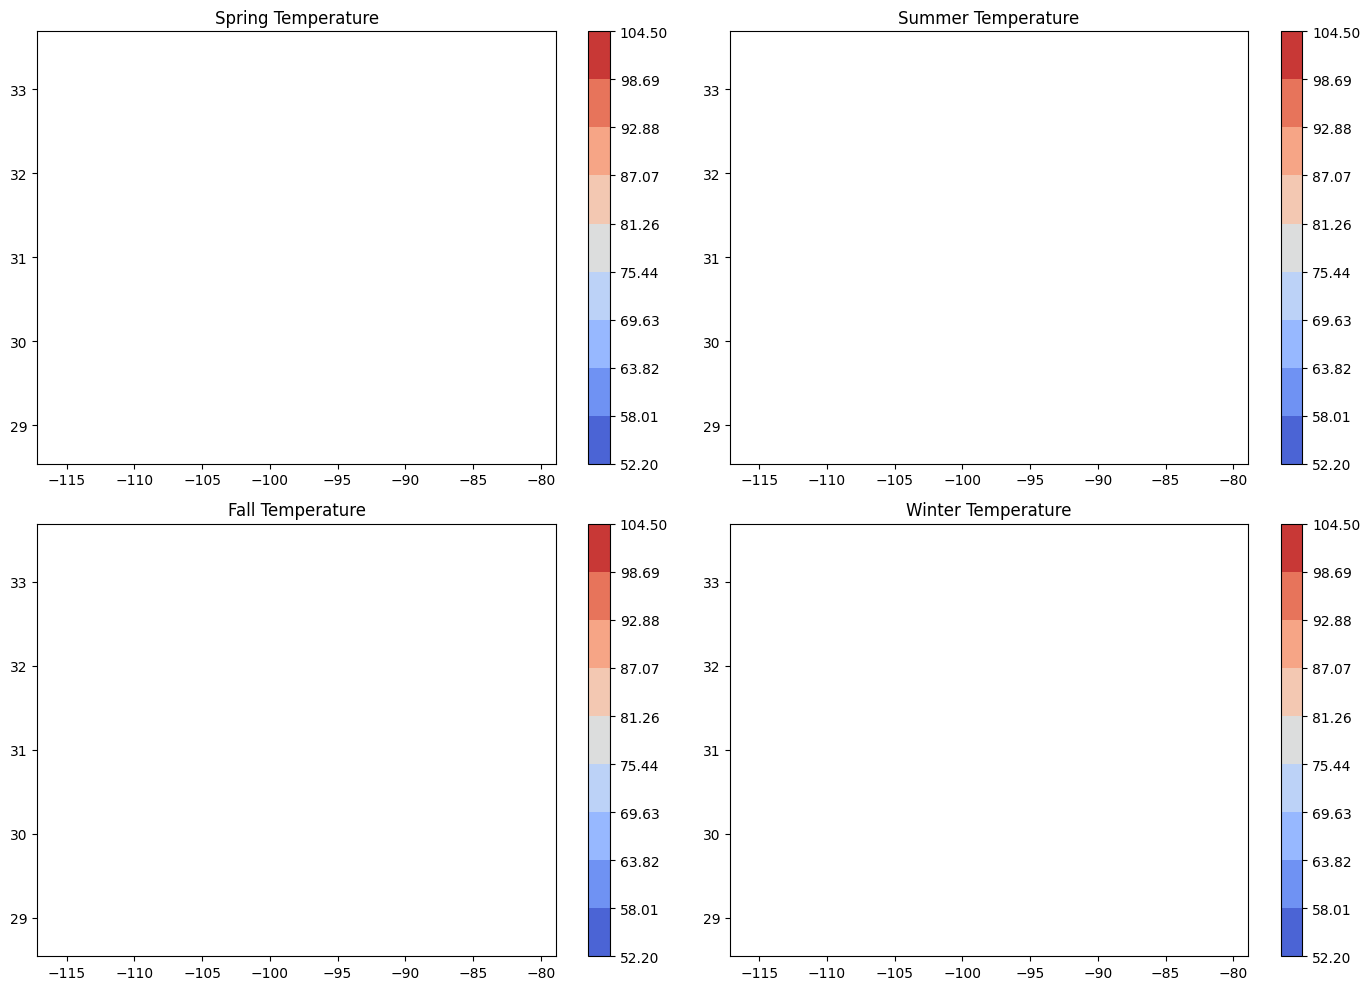What is the temperature range in Phoenix during Spring? Look at the Spring temperature plot and identify the color representing Phoenix. Compare it to the legend to figure out the exact temperature range.
Answer: 75.5°F Which season has the highest average temperature across all locations? Visually compare the contour fills of each subplot (Spring, Summer, Fall, Winter). The subplot with the most red shades indicates the highest temperature.
Answer: Summer How does the winter temperature in San Diego compare to Phoenix? Find the corresponding spots for San Diego and Phoenix in the Winter plot. Compare the color shades to see which one is warmer. The lighter the color, the higher the temperature.
Answer: San Diego is warmer What's the visual difference in the temperature patterns between Spring and Fall in Orlando? Identify Orlando in the Spring and Fall plots and observe the contour colors. Notice if there are color changes, indicating temperature differences.
Answer: Spring is slightly cooler What are the temperature disparities between Myrtle Beach and Austin in the Summer? Locate Myrtle Beach and Austin in the Summer plot, then observe the colors representing them and compare which one has a higher temperature based on the color gradient.
Answer: Austin is hotter 